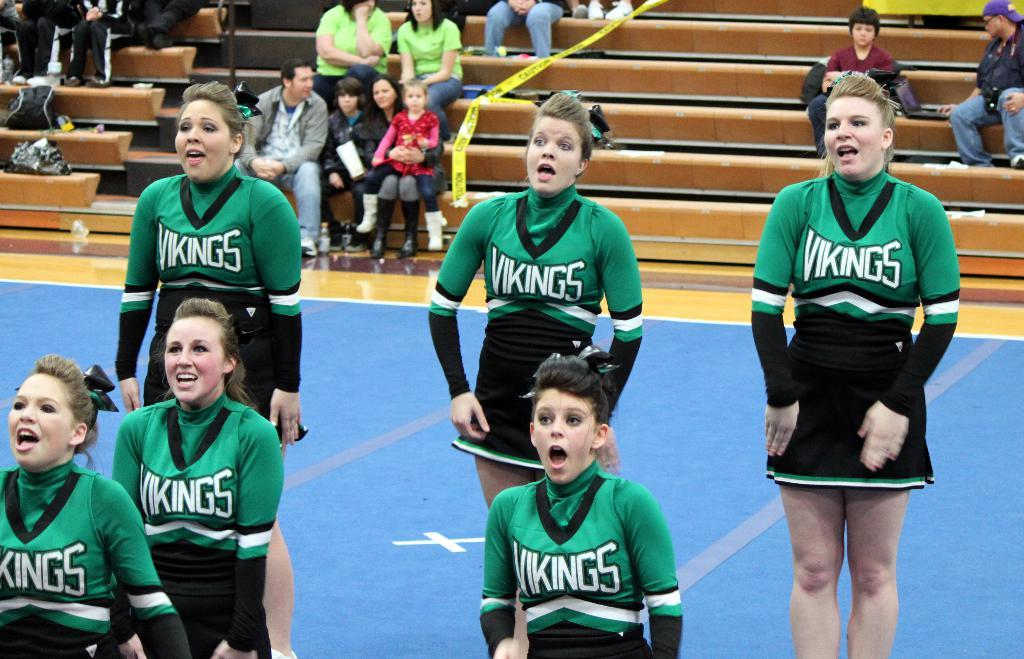<image>
Share a concise interpretation of the image provided. A high school cheer squad performs on court at a Vikings basketball game. 